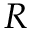<formula> <loc_0><loc_0><loc_500><loc_500>R</formula> 